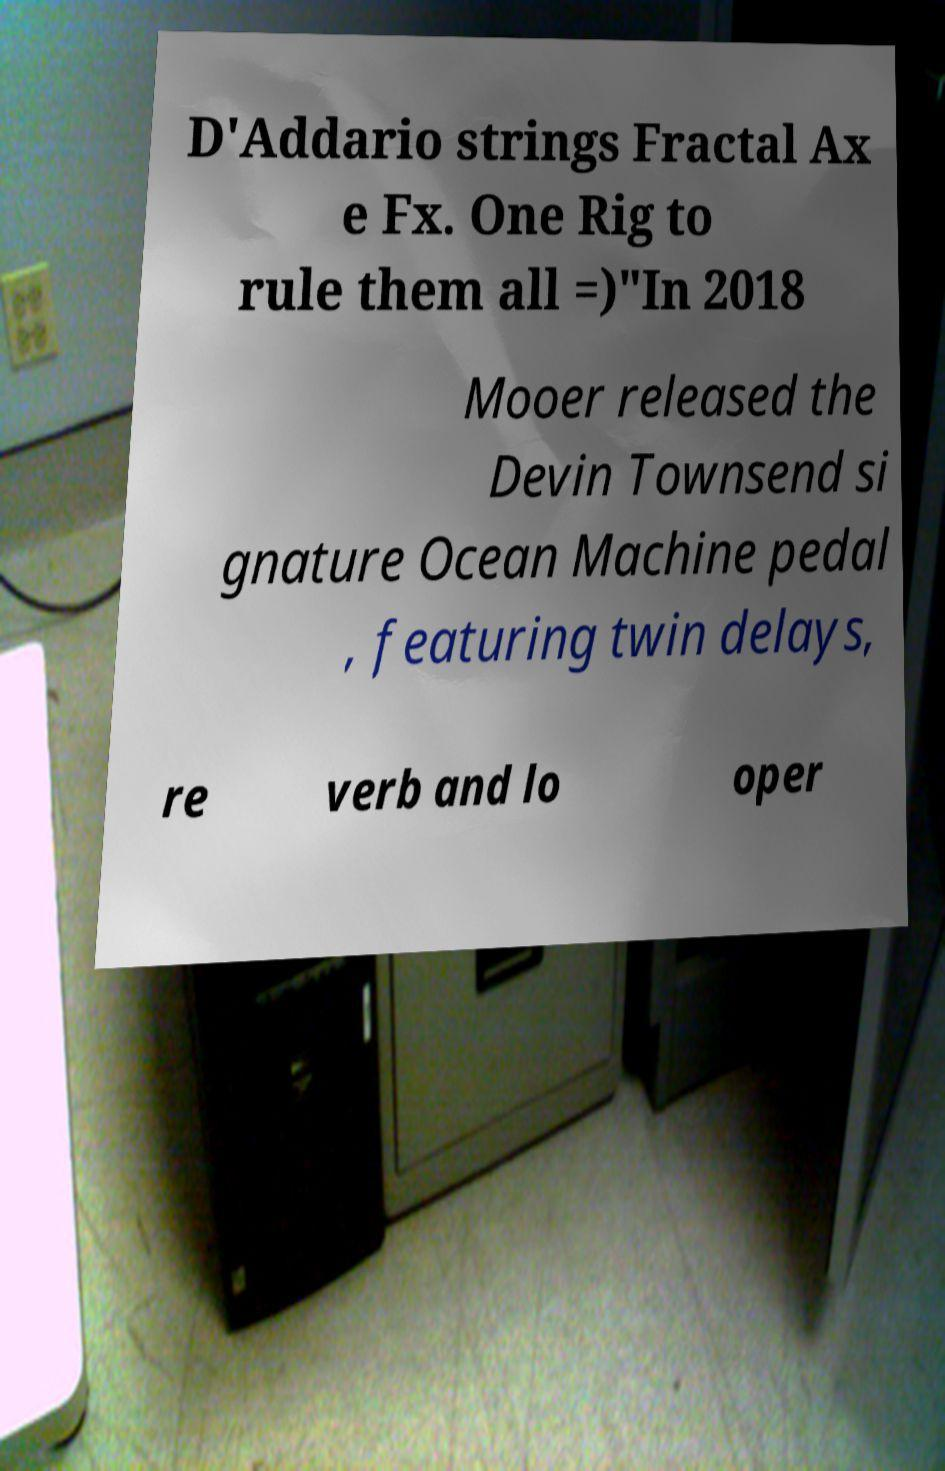Could you extract and type out the text from this image? D'Addario strings Fractal Ax e Fx. One Rig to rule them all =)"In 2018 Mooer released the Devin Townsend si gnature Ocean Machine pedal , featuring twin delays, re verb and lo oper 